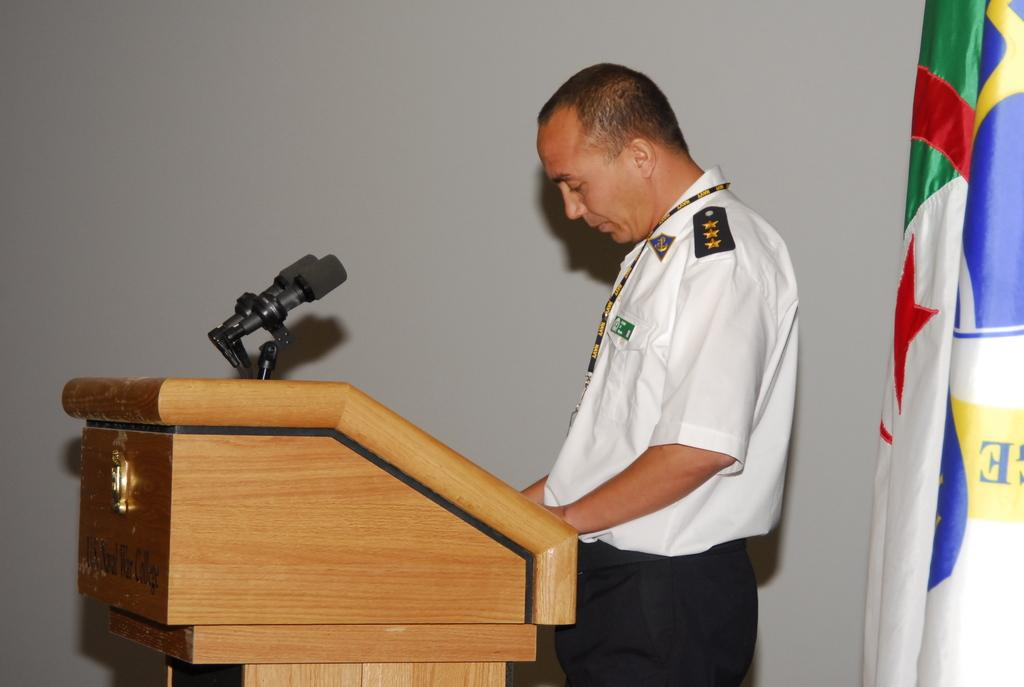What is the person in the image doing? There is a person standing in front of the podium. What object is on the podium? There is a mic on the podium. What can be seen on the right side of the image? There is a flag on the right side of the image. What type of lip can be seen on the person in the image? There is no lip visible on the person in the image; only the person's body and the podium are present. 